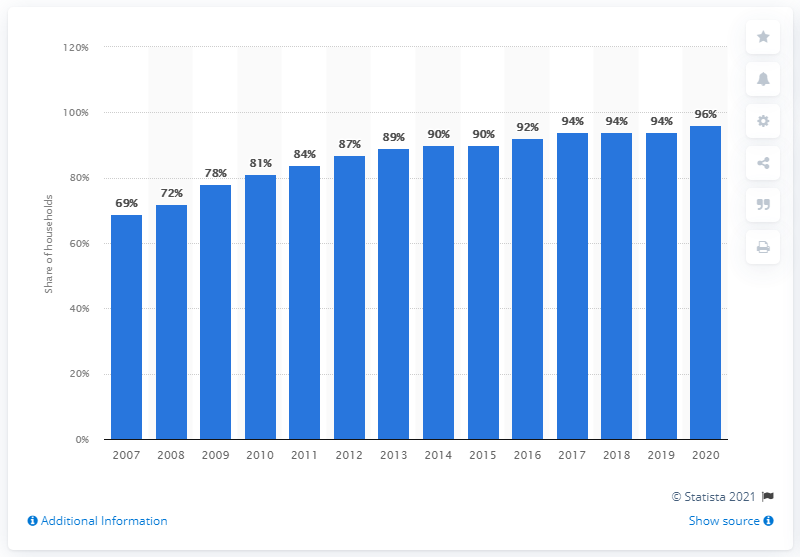Mention a couple of crucial points in this snapshot. In 2020, Finland had the highest percentage of internet coverage among all years. 